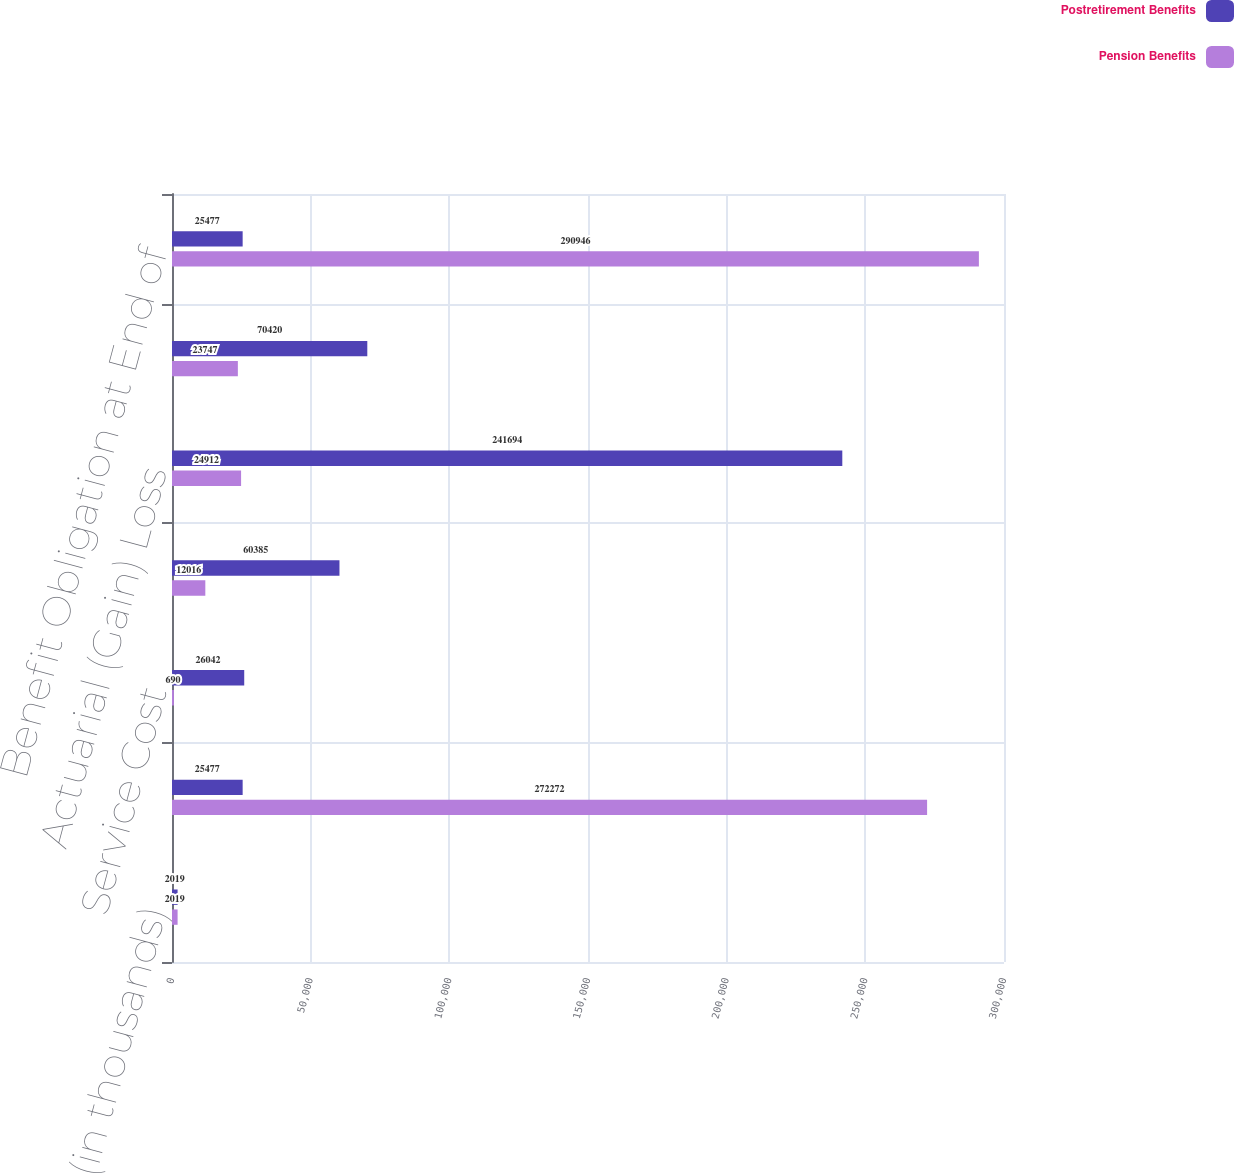Convert chart to OTSL. <chart><loc_0><loc_0><loc_500><loc_500><stacked_bar_chart><ecel><fcel>(in thousands)<fcel>Benefit Obligation at<fcel>Service Cost<fcel>Interest Cost<fcel>Actuarial (Gain) Loss<fcel>Benefits Paid<fcel>Benefit Obligation at End of<nl><fcel>Postretirement Benefits<fcel>2019<fcel>25477<fcel>26042<fcel>60385<fcel>241694<fcel>70420<fcel>25477<nl><fcel>Pension Benefits<fcel>2019<fcel>272272<fcel>690<fcel>12016<fcel>24912<fcel>23747<fcel>290946<nl></chart> 